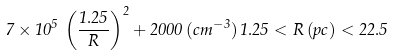<formula> <loc_0><loc_0><loc_500><loc_500>7 \times 1 0 ^ { 5 } \, \left ( \frac { 1 . 2 5 } { R } \right ) ^ { 2 } + 2 0 0 0 \, ( c m ^ { - 3 } ) \, 1 . 2 5 < R \, ( p c ) < 2 2 . 5</formula> 